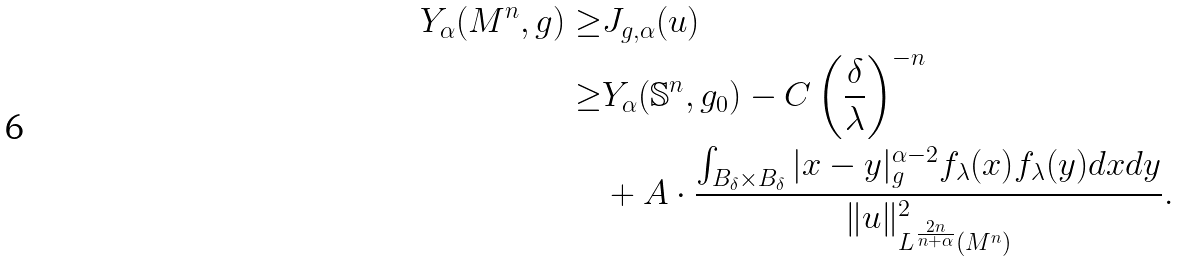<formula> <loc_0><loc_0><loc_500><loc_500>Y _ { \alpha } ( M ^ { n } , g ) \geq & J _ { g , \alpha } ( u ) \\ \geq & Y _ { \alpha } ( \mathbb { S } ^ { n } , g _ { 0 } ) - C \left ( \frac { \delta } { \lambda } \right ) ^ { - n } \\ & + A \cdot \frac { \int _ { B _ { \delta } \times B _ { \delta } } | x - y | _ { g } ^ { \alpha - 2 } f _ { \lambda } ( x ) f _ { \lambda } ( y ) d x d y } { \| u \| _ { L ^ { \frac { 2 n } { n + \alpha } } ( M ^ { n } ) } ^ { 2 } } .</formula> 